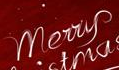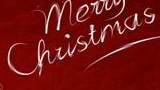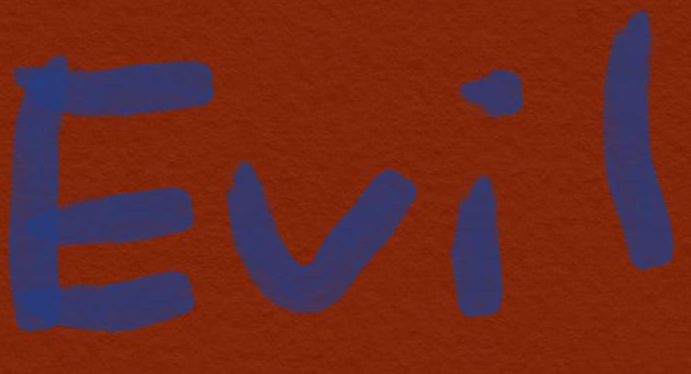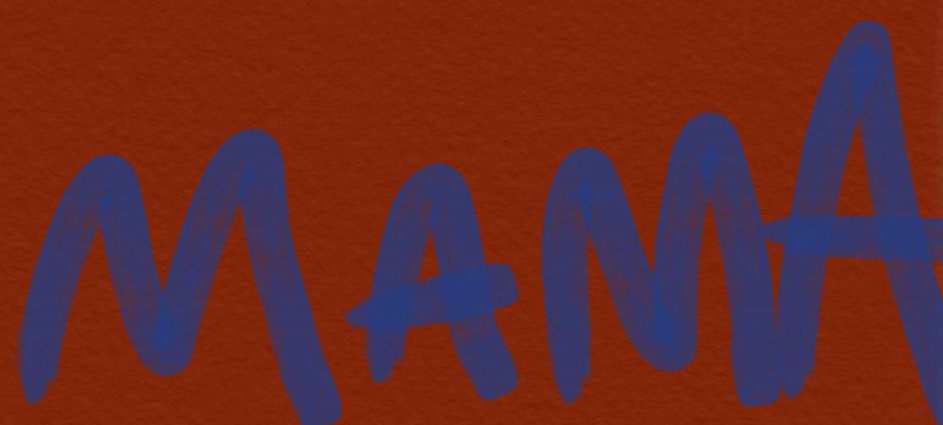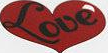Identify the words shown in these images in order, separated by a semicolon. Merry; Christmas; Evil; MAMA; Love 